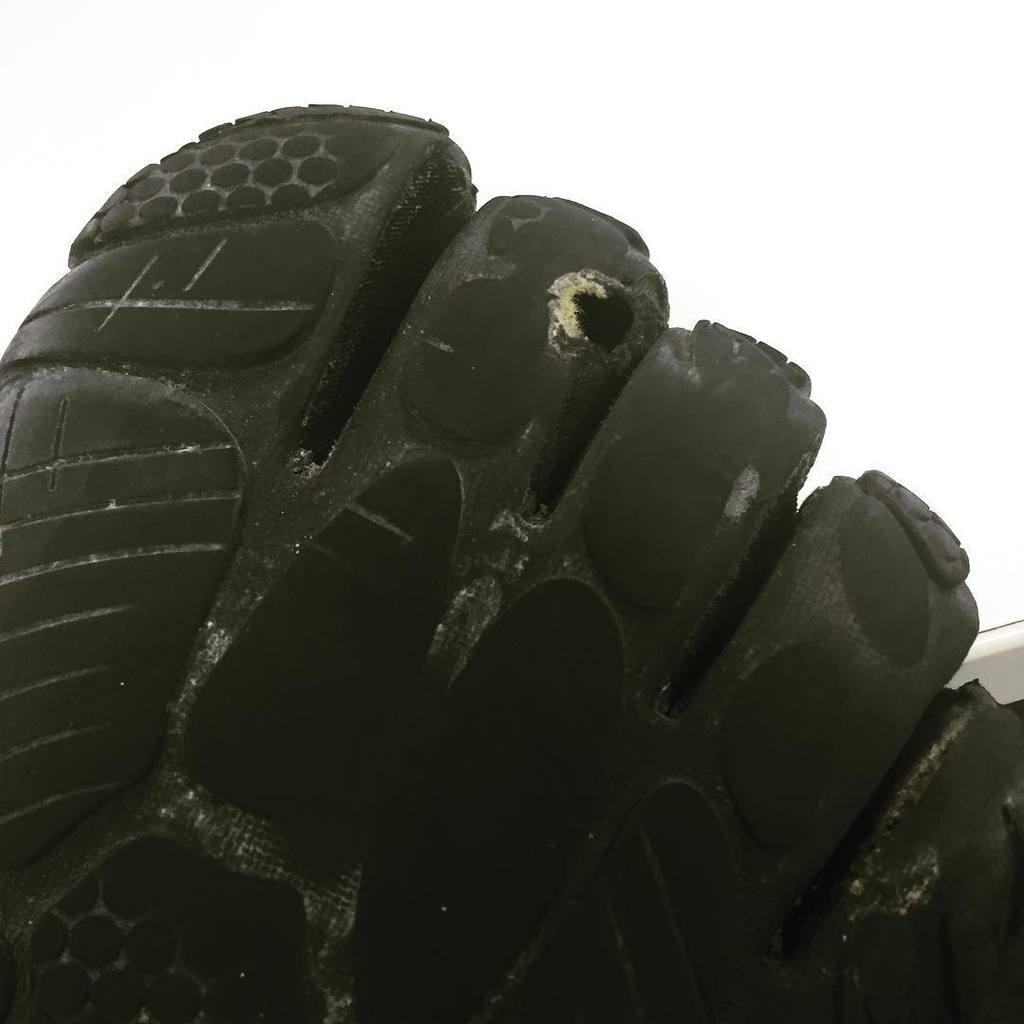Please provide a concise description of this image. In this picture I can see a foot made with some material, and there is white background. 